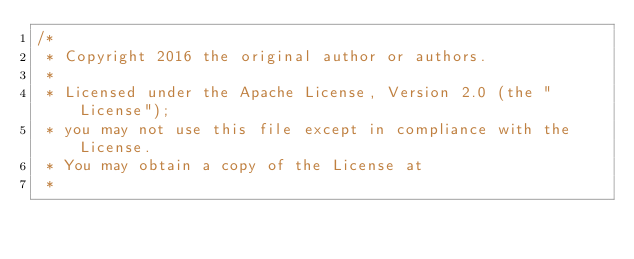Convert code to text. <code><loc_0><loc_0><loc_500><loc_500><_Java_>/*
 * Copyright 2016 the original author or authors.
 *
 * Licensed under the Apache License, Version 2.0 (the "License");
 * you may not use this file except in compliance with the License.
 * You may obtain a copy of the License at
 *</code> 